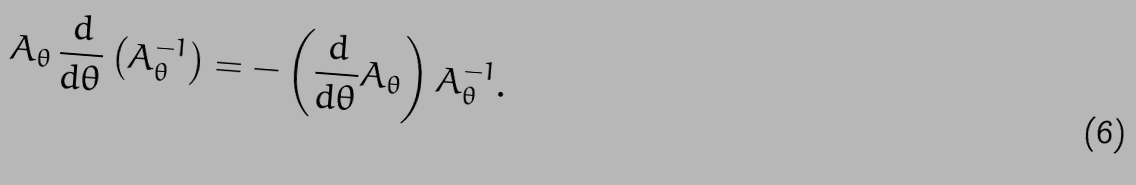<formula> <loc_0><loc_0><loc_500><loc_500>A _ { \theta } \, \frac { d } { d \theta } \left ( A _ { \theta } ^ { - 1 } \right ) = - \left ( \frac { d } { d \theta } A _ { \theta } \right ) A _ { \theta } ^ { - 1 } .</formula> 